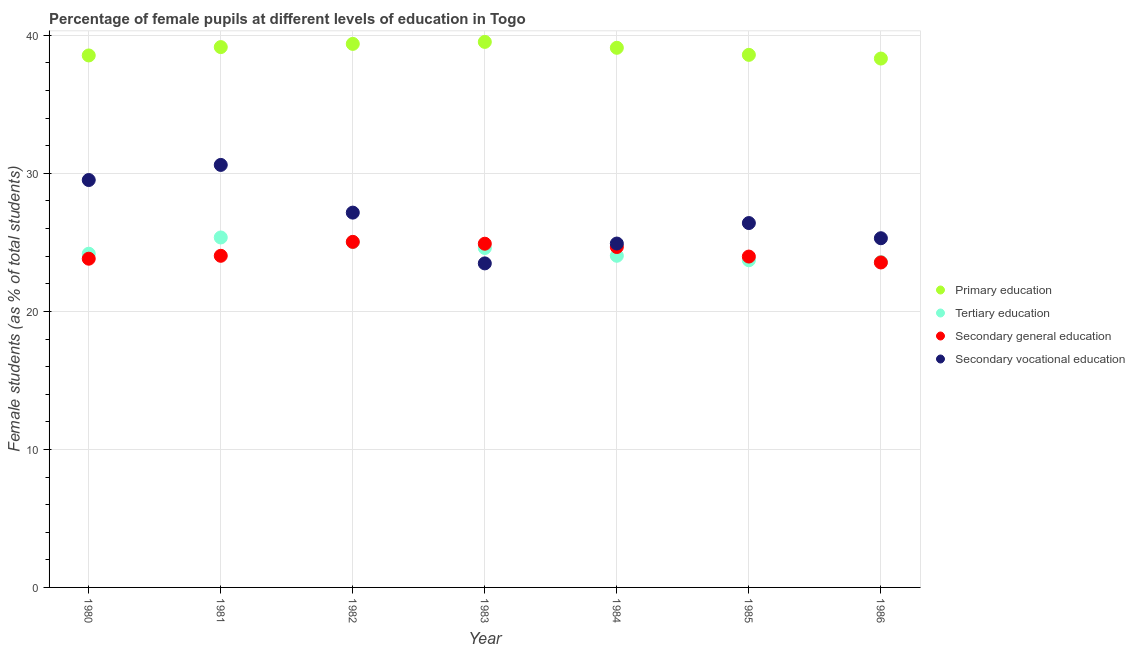What is the percentage of female students in tertiary education in 1981?
Make the answer very short. 25.36. Across all years, what is the maximum percentage of female students in secondary vocational education?
Your response must be concise. 30.61. Across all years, what is the minimum percentage of female students in primary education?
Give a very brief answer. 38.32. In which year was the percentage of female students in secondary vocational education minimum?
Your answer should be compact. 1983. What is the total percentage of female students in primary education in the graph?
Provide a short and direct response. 272.62. What is the difference between the percentage of female students in secondary education in 1980 and that in 1981?
Your answer should be very brief. -0.21. What is the difference between the percentage of female students in secondary education in 1986 and the percentage of female students in tertiary education in 1984?
Ensure brevity in your answer.  -0.49. What is the average percentage of female students in tertiary education per year?
Your answer should be compact. 24.35. In the year 1984, what is the difference between the percentage of female students in tertiary education and percentage of female students in secondary education?
Give a very brief answer. -0.63. What is the ratio of the percentage of female students in tertiary education in 1982 to that in 1985?
Keep it short and to the point. 1.06. Is the difference between the percentage of female students in tertiary education in 1981 and 1984 greater than the difference between the percentage of female students in primary education in 1981 and 1984?
Provide a succinct answer. Yes. What is the difference between the highest and the second highest percentage of female students in secondary vocational education?
Your answer should be very brief. 1.09. What is the difference between the highest and the lowest percentage of female students in tertiary education?
Your answer should be very brief. 1.79. In how many years, is the percentage of female students in tertiary education greater than the average percentage of female students in tertiary education taken over all years?
Provide a short and direct response. 3. Is the sum of the percentage of female students in primary education in 1983 and 1985 greater than the maximum percentage of female students in secondary vocational education across all years?
Ensure brevity in your answer.  Yes. Is it the case that in every year, the sum of the percentage of female students in primary education and percentage of female students in tertiary education is greater than the percentage of female students in secondary education?
Ensure brevity in your answer.  Yes. Does the percentage of female students in secondary education monotonically increase over the years?
Make the answer very short. No. How many dotlines are there?
Your answer should be very brief. 4. What is the difference between two consecutive major ticks on the Y-axis?
Offer a terse response. 10. Are the values on the major ticks of Y-axis written in scientific E-notation?
Offer a very short reply. No. Does the graph contain any zero values?
Give a very brief answer. No. Does the graph contain grids?
Give a very brief answer. Yes. Where does the legend appear in the graph?
Provide a short and direct response. Center right. How many legend labels are there?
Make the answer very short. 4. How are the legend labels stacked?
Your response must be concise. Vertical. What is the title of the graph?
Your response must be concise. Percentage of female pupils at different levels of education in Togo. Does "Public resource use" appear as one of the legend labels in the graph?
Your response must be concise. No. What is the label or title of the Y-axis?
Your answer should be very brief. Female students (as % of total students). What is the Female students (as % of total students) in Primary education in 1980?
Your answer should be compact. 38.55. What is the Female students (as % of total students) in Tertiary education in 1980?
Offer a terse response. 24.18. What is the Female students (as % of total students) of Secondary general education in 1980?
Provide a short and direct response. 23.82. What is the Female students (as % of total students) of Secondary vocational education in 1980?
Ensure brevity in your answer.  29.52. What is the Female students (as % of total students) in Primary education in 1981?
Ensure brevity in your answer.  39.15. What is the Female students (as % of total students) of Tertiary education in 1981?
Offer a very short reply. 25.36. What is the Female students (as % of total students) in Secondary general education in 1981?
Keep it short and to the point. 24.03. What is the Female students (as % of total students) in Secondary vocational education in 1981?
Ensure brevity in your answer.  30.61. What is the Female students (as % of total students) of Primary education in 1982?
Provide a short and direct response. 39.38. What is the Female students (as % of total students) of Tertiary education in 1982?
Ensure brevity in your answer.  25.02. What is the Female students (as % of total students) in Secondary general education in 1982?
Give a very brief answer. 25.04. What is the Female students (as % of total students) of Secondary vocational education in 1982?
Your answer should be compact. 27.16. What is the Female students (as % of total students) of Primary education in 1983?
Your answer should be very brief. 39.53. What is the Female students (as % of total students) of Tertiary education in 1983?
Your response must be concise. 24.59. What is the Female students (as % of total students) in Secondary general education in 1983?
Your response must be concise. 24.9. What is the Female students (as % of total students) of Secondary vocational education in 1983?
Your answer should be compact. 23.48. What is the Female students (as % of total students) in Primary education in 1984?
Keep it short and to the point. 39.1. What is the Female students (as % of total students) of Tertiary education in 1984?
Give a very brief answer. 24.03. What is the Female students (as % of total students) in Secondary general education in 1984?
Your answer should be compact. 24.67. What is the Female students (as % of total students) of Secondary vocational education in 1984?
Provide a short and direct response. 24.92. What is the Female students (as % of total students) in Primary education in 1985?
Make the answer very short. 38.59. What is the Female students (as % of total students) of Tertiary education in 1985?
Keep it short and to the point. 23.71. What is the Female students (as % of total students) of Secondary general education in 1985?
Ensure brevity in your answer.  23.97. What is the Female students (as % of total students) of Secondary vocational education in 1985?
Offer a terse response. 26.4. What is the Female students (as % of total students) in Primary education in 1986?
Make the answer very short. 38.32. What is the Female students (as % of total students) of Tertiary education in 1986?
Ensure brevity in your answer.  23.57. What is the Female students (as % of total students) in Secondary general education in 1986?
Offer a terse response. 23.55. What is the Female students (as % of total students) of Secondary vocational education in 1986?
Offer a very short reply. 25.3. Across all years, what is the maximum Female students (as % of total students) of Primary education?
Give a very brief answer. 39.53. Across all years, what is the maximum Female students (as % of total students) in Tertiary education?
Offer a terse response. 25.36. Across all years, what is the maximum Female students (as % of total students) of Secondary general education?
Ensure brevity in your answer.  25.04. Across all years, what is the maximum Female students (as % of total students) of Secondary vocational education?
Provide a succinct answer. 30.61. Across all years, what is the minimum Female students (as % of total students) of Primary education?
Offer a very short reply. 38.32. Across all years, what is the minimum Female students (as % of total students) in Tertiary education?
Offer a very short reply. 23.57. Across all years, what is the minimum Female students (as % of total students) in Secondary general education?
Give a very brief answer. 23.55. Across all years, what is the minimum Female students (as % of total students) in Secondary vocational education?
Your answer should be very brief. 23.48. What is the total Female students (as % of total students) of Primary education in the graph?
Offer a very short reply. 272.62. What is the total Female students (as % of total students) in Tertiary education in the graph?
Ensure brevity in your answer.  170.47. What is the total Female students (as % of total students) in Secondary general education in the graph?
Your answer should be very brief. 169.98. What is the total Female students (as % of total students) of Secondary vocational education in the graph?
Your response must be concise. 187.39. What is the difference between the Female students (as % of total students) of Primary education in 1980 and that in 1981?
Your response must be concise. -0.61. What is the difference between the Female students (as % of total students) in Tertiary education in 1980 and that in 1981?
Your answer should be compact. -1.18. What is the difference between the Female students (as % of total students) of Secondary general education in 1980 and that in 1981?
Offer a terse response. -0.21. What is the difference between the Female students (as % of total students) in Secondary vocational education in 1980 and that in 1981?
Make the answer very short. -1.09. What is the difference between the Female students (as % of total students) in Primary education in 1980 and that in 1982?
Keep it short and to the point. -0.84. What is the difference between the Female students (as % of total students) of Tertiary education in 1980 and that in 1982?
Your answer should be compact. -0.84. What is the difference between the Female students (as % of total students) of Secondary general education in 1980 and that in 1982?
Offer a very short reply. -1.22. What is the difference between the Female students (as % of total students) of Secondary vocational education in 1980 and that in 1982?
Your response must be concise. 2.36. What is the difference between the Female students (as % of total students) in Primary education in 1980 and that in 1983?
Ensure brevity in your answer.  -0.98. What is the difference between the Female students (as % of total students) of Tertiary education in 1980 and that in 1983?
Provide a succinct answer. -0.42. What is the difference between the Female students (as % of total students) in Secondary general education in 1980 and that in 1983?
Offer a terse response. -1.09. What is the difference between the Female students (as % of total students) of Secondary vocational education in 1980 and that in 1983?
Keep it short and to the point. 6.04. What is the difference between the Female students (as % of total students) of Primary education in 1980 and that in 1984?
Your answer should be compact. -0.55. What is the difference between the Female students (as % of total students) of Tertiary education in 1980 and that in 1984?
Keep it short and to the point. 0.15. What is the difference between the Female students (as % of total students) in Secondary general education in 1980 and that in 1984?
Provide a short and direct response. -0.85. What is the difference between the Female students (as % of total students) in Secondary vocational education in 1980 and that in 1984?
Ensure brevity in your answer.  4.6. What is the difference between the Female students (as % of total students) of Primary education in 1980 and that in 1985?
Provide a short and direct response. -0.04. What is the difference between the Female students (as % of total students) of Tertiary education in 1980 and that in 1985?
Your response must be concise. 0.47. What is the difference between the Female students (as % of total students) in Secondary general education in 1980 and that in 1985?
Offer a very short reply. -0.16. What is the difference between the Female students (as % of total students) in Secondary vocational education in 1980 and that in 1985?
Offer a terse response. 3.12. What is the difference between the Female students (as % of total students) in Primary education in 1980 and that in 1986?
Your answer should be compact. 0.22. What is the difference between the Female students (as % of total students) of Tertiary education in 1980 and that in 1986?
Give a very brief answer. 0.61. What is the difference between the Female students (as % of total students) of Secondary general education in 1980 and that in 1986?
Provide a short and direct response. 0.27. What is the difference between the Female students (as % of total students) of Secondary vocational education in 1980 and that in 1986?
Provide a short and direct response. 4.22. What is the difference between the Female students (as % of total students) in Primary education in 1981 and that in 1982?
Keep it short and to the point. -0.23. What is the difference between the Female students (as % of total students) in Tertiary education in 1981 and that in 1982?
Make the answer very short. 0.33. What is the difference between the Female students (as % of total students) in Secondary general education in 1981 and that in 1982?
Offer a very short reply. -1.01. What is the difference between the Female students (as % of total students) of Secondary vocational education in 1981 and that in 1982?
Give a very brief answer. 3.46. What is the difference between the Female students (as % of total students) of Primary education in 1981 and that in 1983?
Your answer should be compact. -0.38. What is the difference between the Female students (as % of total students) in Tertiary education in 1981 and that in 1983?
Your answer should be very brief. 0.76. What is the difference between the Female students (as % of total students) of Secondary general education in 1981 and that in 1983?
Make the answer very short. -0.88. What is the difference between the Female students (as % of total students) in Secondary vocational education in 1981 and that in 1983?
Ensure brevity in your answer.  7.14. What is the difference between the Female students (as % of total students) in Primary education in 1981 and that in 1984?
Give a very brief answer. 0.05. What is the difference between the Female students (as % of total students) in Tertiary education in 1981 and that in 1984?
Ensure brevity in your answer.  1.33. What is the difference between the Female students (as % of total students) of Secondary general education in 1981 and that in 1984?
Offer a very short reply. -0.64. What is the difference between the Female students (as % of total students) in Secondary vocational education in 1981 and that in 1984?
Provide a succinct answer. 5.7. What is the difference between the Female students (as % of total students) of Primary education in 1981 and that in 1985?
Provide a succinct answer. 0.56. What is the difference between the Female students (as % of total students) in Tertiary education in 1981 and that in 1985?
Give a very brief answer. 1.65. What is the difference between the Female students (as % of total students) of Secondary general education in 1981 and that in 1985?
Your answer should be very brief. 0.05. What is the difference between the Female students (as % of total students) of Secondary vocational education in 1981 and that in 1985?
Your answer should be compact. 4.21. What is the difference between the Female students (as % of total students) in Primary education in 1981 and that in 1986?
Make the answer very short. 0.83. What is the difference between the Female students (as % of total students) in Tertiary education in 1981 and that in 1986?
Give a very brief answer. 1.79. What is the difference between the Female students (as % of total students) in Secondary general education in 1981 and that in 1986?
Your response must be concise. 0.48. What is the difference between the Female students (as % of total students) of Secondary vocational education in 1981 and that in 1986?
Provide a short and direct response. 5.31. What is the difference between the Female students (as % of total students) in Primary education in 1982 and that in 1983?
Ensure brevity in your answer.  -0.14. What is the difference between the Female students (as % of total students) in Tertiary education in 1982 and that in 1983?
Offer a terse response. 0.43. What is the difference between the Female students (as % of total students) of Secondary general education in 1982 and that in 1983?
Provide a succinct answer. 0.13. What is the difference between the Female students (as % of total students) in Secondary vocational education in 1982 and that in 1983?
Provide a succinct answer. 3.68. What is the difference between the Female students (as % of total students) in Primary education in 1982 and that in 1984?
Offer a very short reply. 0.28. What is the difference between the Female students (as % of total students) of Secondary general education in 1982 and that in 1984?
Keep it short and to the point. 0.37. What is the difference between the Female students (as % of total students) of Secondary vocational education in 1982 and that in 1984?
Offer a terse response. 2.24. What is the difference between the Female students (as % of total students) of Primary education in 1982 and that in 1985?
Ensure brevity in your answer.  0.79. What is the difference between the Female students (as % of total students) in Tertiary education in 1982 and that in 1985?
Offer a very short reply. 1.32. What is the difference between the Female students (as % of total students) in Secondary general education in 1982 and that in 1985?
Offer a terse response. 1.06. What is the difference between the Female students (as % of total students) in Secondary vocational education in 1982 and that in 1985?
Keep it short and to the point. 0.76. What is the difference between the Female students (as % of total students) of Primary education in 1982 and that in 1986?
Ensure brevity in your answer.  1.06. What is the difference between the Female students (as % of total students) of Tertiary education in 1982 and that in 1986?
Keep it short and to the point. 1.45. What is the difference between the Female students (as % of total students) in Secondary general education in 1982 and that in 1986?
Keep it short and to the point. 1.49. What is the difference between the Female students (as % of total students) of Secondary vocational education in 1982 and that in 1986?
Provide a succinct answer. 1.86. What is the difference between the Female students (as % of total students) of Primary education in 1983 and that in 1984?
Make the answer very short. 0.43. What is the difference between the Female students (as % of total students) of Tertiary education in 1983 and that in 1984?
Keep it short and to the point. 0.56. What is the difference between the Female students (as % of total students) in Secondary general education in 1983 and that in 1984?
Your response must be concise. 0.24. What is the difference between the Female students (as % of total students) in Secondary vocational education in 1983 and that in 1984?
Provide a short and direct response. -1.44. What is the difference between the Female students (as % of total students) of Primary education in 1983 and that in 1985?
Give a very brief answer. 0.94. What is the difference between the Female students (as % of total students) in Tertiary education in 1983 and that in 1985?
Offer a very short reply. 0.89. What is the difference between the Female students (as % of total students) of Secondary general education in 1983 and that in 1985?
Provide a short and direct response. 0.93. What is the difference between the Female students (as % of total students) in Secondary vocational education in 1983 and that in 1985?
Keep it short and to the point. -2.92. What is the difference between the Female students (as % of total students) of Primary education in 1983 and that in 1986?
Ensure brevity in your answer.  1.21. What is the difference between the Female students (as % of total students) in Tertiary education in 1983 and that in 1986?
Make the answer very short. 1.02. What is the difference between the Female students (as % of total students) of Secondary general education in 1983 and that in 1986?
Offer a terse response. 1.36. What is the difference between the Female students (as % of total students) of Secondary vocational education in 1983 and that in 1986?
Offer a very short reply. -1.82. What is the difference between the Female students (as % of total students) of Primary education in 1984 and that in 1985?
Provide a short and direct response. 0.51. What is the difference between the Female students (as % of total students) of Tertiary education in 1984 and that in 1985?
Your answer should be very brief. 0.32. What is the difference between the Female students (as % of total students) of Secondary general education in 1984 and that in 1985?
Provide a short and direct response. 0.69. What is the difference between the Female students (as % of total students) in Secondary vocational education in 1984 and that in 1985?
Ensure brevity in your answer.  -1.48. What is the difference between the Female students (as % of total students) in Primary education in 1984 and that in 1986?
Offer a very short reply. 0.78. What is the difference between the Female students (as % of total students) in Tertiary education in 1984 and that in 1986?
Provide a succinct answer. 0.46. What is the difference between the Female students (as % of total students) in Secondary general education in 1984 and that in 1986?
Offer a very short reply. 1.12. What is the difference between the Female students (as % of total students) in Secondary vocational education in 1984 and that in 1986?
Make the answer very short. -0.38. What is the difference between the Female students (as % of total students) of Primary education in 1985 and that in 1986?
Make the answer very short. 0.27. What is the difference between the Female students (as % of total students) in Tertiary education in 1985 and that in 1986?
Offer a terse response. 0.14. What is the difference between the Female students (as % of total students) of Secondary general education in 1985 and that in 1986?
Make the answer very short. 0.43. What is the difference between the Female students (as % of total students) in Secondary vocational education in 1985 and that in 1986?
Give a very brief answer. 1.1. What is the difference between the Female students (as % of total students) of Primary education in 1980 and the Female students (as % of total students) of Tertiary education in 1981?
Make the answer very short. 13.19. What is the difference between the Female students (as % of total students) of Primary education in 1980 and the Female students (as % of total students) of Secondary general education in 1981?
Ensure brevity in your answer.  14.52. What is the difference between the Female students (as % of total students) in Primary education in 1980 and the Female students (as % of total students) in Secondary vocational education in 1981?
Keep it short and to the point. 7.93. What is the difference between the Female students (as % of total students) in Tertiary education in 1980 and the Female students (as % of total students) in Secondary general education in 1981?
Your response must be concise. 0.15. What is the difference between the Female students (as % of total students) of Tertiary education in 1980 and the Female students (as % of total students) of Secondary vocational education in 1981?
Offer a very short reply. -6.43. What is the difference between the Female students (as % of total students) in Secondary general education in 1980 and the Female students (as % of total students) in Secondary vocational education in 1981?
Provide a succinct answer. -6.8. What is the difference between the Female students (as % of total students) of Primary education in 1980 and the Female students (as % of total students) of Tertiary education in 1982?
Your answer should be very brief. 13.52. What is the difference between the Female students (as % of total students) of Primary education in 1980 and the Female students (as % of total students) of Secondary general education in 1982?
Offer a very short reply. 13.51. What is the difference between the Female students (as % of total students) of Primary education in 1980 and the Female students (as % of total students) of Secondary vocational education in 1982?
Provide a succinct answer. 11.39. What is the difference between the Female students (as % of total students) of Tertiary education in 1980 and the Female students (as % of total students) of Secondary general education in 1982?
Offer a terse response. -0.86. What is the difference between the Female students (as % of total students) of Tertiary education in 1980 and the Female students (as % of total students) of Secondary vocational education in 1982?
Provide a succinct answer. -2.98. What is the difference between the Female students (as % of total students) in Secondary general education in 1980 and the Female students (as % of total students) in Secondary vocational education in 1982?
Keep it short and to the point. -3.34. What is the difference between the Female students (as % of total students) of Primary education in 1980 and the Female students (as % of total students) of Tertiary education in 1983?
Your answer should be compact. 13.95. What is the difference between the Female students (as % of total students) in Primary education in 1980 and the Female students (as % of total students) in Secondary general education in 1983?
Your answer should be very brief. 13.64. What is the difference between the Female students (as % of total students) in Primary education in 1980 and the Female students (as % of total students) in Secondary vocational education in 1983?
Provide a short and direct response. 15.07. What is the difference between the Female students (as % of total students) of Tertiary education in 1980 and the Female students (as % of total students) of Secondary general education in 1983?
Offer a terse response. -0.73. What is the difference between the Female students (as % of total students) in Tertiary education in 1980 and the Female students (as % of total students) in Secondary vocational education in 1983?
Your answer should be compact. 0.7. What is the difference between the Female students (as % of total students) of Secondary general education in 1980 and the Female students (as % of total students) of Secondary vocational education in 1983?
Provide a short and direct response. 0.34. What is the difference between the Female students (as % of total students) in Primary education in 1980 and the Female students (as % of total students) in Tertiary education in 1984?
Your answer should be compact. 14.52. What is the difference between the Female students (as % of total students) of Primary education in 1980 and the Female students (as % of total students) of Secondary general education in 1984?
Your answer should be very brief. 13.88. What is the difference between the Female students (as % of total students) in Primary education in 1980 and the Female students (as % of total students) in Secondary vocational education in 1984?
Give a very brief answer. 13.63. What is the difference between the Female students (as % of total students) in Tertiary education in 1980 and the Female students (as % of total students) in Secondary general education in 1984?
Your answer should be very brief. -0.49. What is the difference between the Female students (as % of total students) in Tertiary education in 1980 and the Female students (as % of total students) in Secondary vocational education in 1984?
Give a very brief answer. -0.74. What is the difference between the Female students (as % of total students) in Secondary general education in 1980 and the Female students (as % of total students) in Secondary vocational education in 1984?
Offer a terse response. -1.1. What is the difference between the Female students (as % of total students) of Primary education in 1980 and the Female students (as % of total students) of Tertiary education in 1985?
Offer a terse response. 14.84. What is the difference between the Female students (as % of total students) in Primary education in 1980 and the Female students (as % of total students) in Secondary general education in 1985?
Your answer should be very brief. 14.57. What is the difference between the Female students (as % of total students) of Primary education in 1980 and the Female students (as % of total students) of Secondary vocational education in 1985?
Give a very brief answer. 12.14. What is the difference between the Female students (as % of total students) in Tertiary education in 1980 and the Female students (as % of total students) in Secondary general education in 1985?
Your answer should be very brief. 0.2. What is the difference between the Female students (as % of total students) of Tertiary education in 1980 and the Female students (as % of total students) of Secondary vocational education in 1985?
Give a very brief answer. -2.22. What is the difference between the Female students (as % of total students) of Secondary general education in 1980 and the Female students (as % of total students) of Secondary vocational education in 1985?
Ensure brevity in your answer.  -2.58. What is the difference between the Female students (as % of total students) in Primary education in 1980 and the Female students (as % of total students) in Tertiary education in 1986?
Your answer should be very brief. 14.97. What is the difference between the Female students (as % of total students) of Primary education in 1980 and the Female students (as % of total students) of Secondary general education in 1986?
Provide a short and direct response. 15. What is the difference between the Female students (as % of total students) of Primary education in 1980 and the Female students (as % of total students) of Secondary vocational education in 1986?
Offer a very short reply. 13.24. What is the difference between the Female students (as % of total students) of Tertiary education in 1980 and the Female students (as % of total students) of Secondary general education in 1986?
Your answer should be compact. 0.63. What is the difference between the Female students (as % of total students) of Tertiary education in 1980 and the Female students (as % of total students) of Secondary vocational education in 1986?
Offer a terse response. -1.12. What is the difference between the Female students (as % of total students) in Secondary general education in 1980 and the Female students (as % of total students) in Secondary vocational education in 1986?
Ensure brevity in your answer.  -1.48. What is the difference between the Female students (as % of total students) in Primary education in 1981 and the Female students (as % of total students) in Tertiary education in 1982?
Your response must be concise. 14.13. What is the difference between the Female students (as % of total students) of Primary education in 1981 and the Female students (as % of total students) of Secondary general education in 1982?
Your answer should be very brief. 14.11. What is the difference between the Female students (as % of total students) of Primary education in 1981 and the Female students (as % of total students) of Secondary vocational education in 1982?
Your answer should be very brief. 11.99. What is the difference between the Female students (as % of total students) of Tertiary education in 1981 and the Female students (as % of total students) of Secondary general education in 1982?
Keep it short and to the point. 0.32. What is the difference between the Female students (as % of total students) of Tertiary education in 1981 and the Female students (as % of total students) of Secondary vocational education in 1982?
Your response must be concise. -1.8. What is the difference between the Female students (as % of total students) in Secondary general education in 1981 and the Female students (as % of total students) in Secondary vocational education in 1982?
Ensure brevity in your answer.  -3.13. What is the difference between the Female students (as % of total students) of Primary education in 1981 and the Female students (as % of total students) of Tertiary education in 1983?
Your answer should be compact. 14.56. What is the difference between the Female students (as % of total students) in Primary education in 1981 and the Female students (as % of total students) in Secondary general education in 1983?
Your answer should be compact. 14.25. What is the difference between the Female students (as % of total students) of Primary education in 1981 and the Female students (as % of total students) of Secondary vocational education in 1983?
Offer a terse response. 15.67. What is the difference between the Female students (as % of total students) of Tertiary education in 1981 and the Female students (as % of total students) of Secondary general education in 1983?
Provide a short and direct response. 0.45. What is the difference between the Female students (as % of total students) of Tertiary education in 1981 and the Female students (as % of total students) of Secondary vocational education in 1983?
Offer a terse response. 1.88. What is the difference between the Female students (as % of total students) in Secondary general education in 1981 and the Female students (as % of total students) in Secondary vocational education in 1983?
Your answer should be very brief. 0.55. What is the difference between the Female students (as % of total students) in Primary education in 1981 and the Female students (as % of total students) in Tertiary education in 1984?
Keep it short and to the point. 15.12. What is the difference between the Female students (as % of total students) in Primary education in 1981 and the Female students (as % of total students) in Secondary general education in 1984?
Give a very brief answer. 14.49. What is the difference between the Female students (as % of total students) of Primary education in 1981 and the Female students (as % of total students) of Secondary vocational education in 1984?
Keep it short and to the point. 14.23. What is the difference between the Female students (as % of total students) of Tertiary education in 1981 and the Female students (as % of total students) of Secondary general education in 1984?
Provide a short and direct response. 0.69. What is the difference between the Female students (as % of total students) of Tertiary education in 1981 and the Female students (as % of total students) of Secondary vocational education in 1984?
Give a very brief answer. 0.44. What is the difference between the Female students (as % of total students) in Secondary general education in 1981 and the Female students (as % of total students) in Secondary vocational education in 1984?
Provide a succinct answer. -0.89. What is the difference between the Female students (as % of total students) of Primary education in 1981 and the Female students (as % of total students) of Tertiary education in 1985?
Ensure brevity in your answer.  15.44. What is the difference between the Female students (as % of total students) of Primary education in 1981 and the Female students (as % of total students) of Secondary general education in 1985?
Your response must be concise. 15.18. What is the difference between the Female students (as % of total students) of Primary education in 1981 and the Female students (as % of total students) of Secondary vocational education in 1985?
Ensure brevity in your answer.  12.75. What is the difference between the Female students (as % of total students) in Tertiary education in 1981 and the Female students (as % of total students) in Secondary general education in 1985?
Ensure brevity in your answer.  1.38. What is the difference between the Female students (as % of total students) of Tertiary education in 1981 and the Female students (as % of total students) of Secondary vocational education in 1985?
Keep it short and to the point. -1.04. What is the difference between the Female students (as % of total students) in Secondary general education in 1981 and the Female students (as % of total students) in Secondary vocational education in 1985?
Give a very brief answer. -2.37. What is the difference between the Female students (as % of total students) of Primary education in 1981 and the Female students (as % of total students) of Tertiary education in 1986?
Provide a succinct answer. 15.58. What is the difference between the Female students (as % of total students) in Primary education in 1981 and the Female students (as % of total students) in Secondary general education in 1986?
Offer a terse response. 15.61. What is the difference between the Female students (as % of total students) in Primary education in 1981 and the Female students (as % of total students) in Secondary vocational education in 1986?
Your answer should be very brief. 13.85. What is the difference between the Female students (as % of total students) in Tertiary education in 1981 and the Female students (as % of total students) in Secondary general education in 1986?
Your answer should be compact. 1.81. What is the difference between the Female students (as % of total students) in Tertiary education in 1981 and the Female students (as % of total students) in Secondary vocational education in 1986?
Ensure brevity in your answer.  0.05. What is the difference between the Female students (as % of total students) of Secondary general education in 1981 and the Female students (as % of total students) of Secondary vocational education in 1986?
Offer a very short reply. -1.27. What is the difference between the Female students (as % of total students) of Primary education in 1982 and the Female students (as % of total students) of Tertiary education in 1983?
Offer a very short reply. 14.79. What is the difference between the Female students (as % of total students) in Primary education in 1982 and the Female students (as % of total students) in Secondary general education in 1983?
Make the answer very short. 14.48. What is the difference between the Female students (as % of total students) in Primary education in 1982 and the Female students (as % of total students) in Secondary vocational education in 1983?
Provide a succinct answer. 15.91. What is the difference between the Female students (as % of total students) in Tertiary education in 1982 and the Female students (as % of total students) in Secondary general education in 1983?
Offer a terse response. 0.12. What is the difference between the Female students (as % of total students) in Tertiary education in 1982 and the Female students (as % of total students) in Secondary vocational education in 1983?
Your response must be concise. 1.54. What is the difference between the Female students (as % of total students) of Secondary general education in 1982 and the Female students (as % of total students) of Secondary vocational education in 1983?
Make the answer very short. 1.56. What is the difference between the Female students (as % of total students) of Primary education in 1982 and the Female students (as % of total students) of Tertiary education in 1984?
Your answer should be compact. 15.35. What is the difference between the Female students (as % of total students) in Primary education in 1982 and the Female students (as % of total students) in Secondary general education in 1984?
Keep it short and to the point. 14.72. What is the difference between the Female students (as % of total students) in Primary education in 1982 and the Female students (as % of total students) in Secondary vocational education in 1984?
Give a very brief answer. 14.47. What is the difference between the Female students (as % of total students) in Tertiary education in 1982 and the Female students (as % of total students) in Secondary general education in 1984?
Ensure brevity in your answer.  0.36. What is the difference between the Female students (as % of total students) in Tertiary education in 1982 and the Female students (as % of total students) in Secondary vocational education in 1984?
Your answer should be very brief. 0.11. What is the difference between the Female students (as % of total students) of Secondary general education in 1982 and the Female students (as % of total students) of Secondary vocational education in 1984?
Offer a very short reply. 0.12. What is the difference between the Female students (as % of total students) of Primary education in 1982 and the Female students (as % of total students) of Tertiary education in 1985?
Keep it short and to the point. 15.68. What is the difference between the Female students (as % of total students) of Primary education in 1982 and the Female students (as % of total students) of Secondary general education in 1985?
Keep it short and to the point. 15.41. What is the difference between the Female students (as % of total students) of Primary education in 1982 and the Female students (as % of total students) of Secondary vocational education in 1985?
Offer a very short reply. 12.98. What is the difference between the Female students (as % of total students) in Tertiary education in 1982 and the Female students (as % of total students) in Secondary general education in 1985?
Your answer should be compact. 1.05. What is the difference between the Female students (as % of total students) in Tertiary education in 1982 and the Female students (as % of total students) in Secondary vocational education in 1985?
Your response must be concise. -1.38. What is the difference between the Female students (as % of total students) of Secondary general education in 1982 and the Female students (as % of total students) of Secondary vocational education in 1985?
Give a very brief answer. -1.36. What is the difference between the Female students (as % of total students) in Primary education in 1982 and the Female students (as % of total students) in Tertiary education in 1986?
Provide a short and direct response. 15.81. What is the difference between the Female students (as % of total students) in Primary education in 1982 and the Female students (as % of total students) in Secondary general education in 1986?
Your answer should be very brief. 15.84. What is the difference between the Female students (as % of total students) in Primary education in 1982 and the Female students (as % of total students) in Secondary vocational education in 1986?
Your response must be concise. 14.08. What is the difference between the Female students (as % of total students) of Tertiary education in 1982 and the Female students (as % of total students) of Secondary general education in 1986?
Make the answer very short. 1.48. What is the difference between the Female students (as % of total students) in Tertiary education in 1982 and the Female students (as % of total students) in Secondary vocational education in 1986?
Make the answer very short. -0.28. What is the difference between the Female students (as % of total students) of Secondary general education in 1982 and the Female students (as % of total students) of Secondary vocational education in 1986?
Keep it short and to the point. -0.26. What is the difference between the Female students (as % of total students) in Primary education in 1983 and the Female students (as % of total students) in Tertiary education in 1984?
Keep it short and to the point. 15.5. What is the difference between the Female students (as % of total students) in Primary education in 1983 and the Female students (as % of total students) in Secondary general education in 1984?
Make the answer very short. 14.86. What is the difference between the Female students (as % of total students) in Primary education in 1983 and the Female students (as % of total students) in Secondary vocational education in 1984?
Make the answer very short. 14.61. What is the difference between the Female students (as % of total students) in Tertiary education in 1983 and the Female students (as % of total students) in Secondary general education in 1984?
Make the answer very short. -0.07. What is the difference between the Female students (as % of total students) of Tertiary education in 1983 and the Female students (as % of total students) of Secondary vocational education in 1984?
Keep it short and to the point. -0.32. What is the difference between the Female students (as % of total students) in Secondary general education in 1983 and the Female students (as % of total students) in Secondary vocational education in 1984?
Your answer should be very brief. -0.01. What is the difference between the Female students (as % of total students) of Primary education in 1983 and the Female students (as % of total students) of Tertiary education in 1985?
Give a very brief answer. 15.82. What is the difference between the Female students (as % of total students) of Primary education in 1983 and the Female students (as % of total students) of Secondary general education in 1985?
Offer a very short reply. 15.55. What is the difference between the Female students (as % of total students) in Primary education in 1983 and the Female students (as % of total students) in Secondary vocational education in 1985?
Your answer should be very brief. 13.13. What is the difference between the Female students (as % of total students) in Tertiary education in 1983 and the Female students (as % of total students) in Secondary general education in 1985?
Give a very brief answer. 0.62. What is the difference between the Female students (as % of total students) in Tertiary education in 1983 and the Female students (as % of total students) in Secondary vocational education in 1985?
Make the answer very short. -1.81. What is the difference between the Female students (as % of total students) of Secondary general education in 1983 and the Female students (as % of total students) of Secondary vocational education in 1985?
Offer a very short reply. -1.5. What is the difference between the Female students (as % of total students) in Primary education in 1983 and the Female students (as % of total students) in Tertiary education in 1986?
Make the answer very short. 15.96. What is the difference between the Female students (as % of total students) of Primary education in 1983 and the Female students (as % of total students) of Secondary general education in 1986?
Your response must be concise. 15.98. What is the difference between the Female students (as % of total students) of Primary education in 1983 and the Female students (as % of total students) of Secondary vocational education in 1986?
Make the answer very short. 14.23. What is the difference between the Female students (as % of total students) of Tertiary education in 1983 and the Female students (as % of total students) of Secondary general education in 1986?
Provide a succinct answer. 1.05. What is the difference between the Female students (as % of total students) of Tertiary education in 1983 and the Female students (as % of total students) of Secondary vocational education in 1986?
Offer a very short reply. -0.71. What is the difference between the Female students (as % of total students) in Secondary general education in 1983 and the Female students (as % of total students) in Secondary vocational education in 1986?
Provide a succinct answer. -0.4. What is the difference between the Female students (as % of total students) in Primary education in 1984 and the Female students (as % of total students) in Tertiary education in 1985?
Ensure brevity in your answer.  15.39. What is the difference between the Female students (as % of total students) in Primary education in 1984 and the Female students (as % of total students) in Secondary general education in 1985?
Your response must be concise. 15.13. What is the difference between the Female students (as % of total students) in Primary education in 1984 and the Female students (as % of total students) in Secondary vocational education in 1985?
Your answer should be very brief. 12.7. What is the difference between the Female students (as % of total students) in Tertiary education in 1984 and the Female students (as % of total students) in Secondary general education in 1985?
Make the answer very short. 0.06. What is the difference between the Female students (as % of total students) of Tertiary education in 1984 and the Female students (as % of total students) of Secondary vocational education in 1985?
Your response must be concise. -2.37. What is the difference between the Female students (as % of total students) of Secondary general education in 1984 and the Female students (as % of total students) of Secondary vocational education in 1985?
Ensure brevity in your answer.  -1.74. What is the difference between the Female students (as % of total students) in Primary education in 1984 and the Female students (as % of total students) in Tertiary education in 1986?
Offer a terse response. 15.53. What is the difference between the Female students (as % of total students) in Primary education in 1984 and the Female students (as % of total students) in Secondary general education in 1986?
Offer a terse response. 15.55. What is the difference between the Female students (as % of total students) of Primary education in 1984 and the Female students (as % of total students) of Secondary vocational education in 1986?
Provide a succinct answer. 13.8. What is the difference between the Female students (as % of total students) of Tertiary education in 1984 and the Female students (as % of total students) of Secondary general education in 1986?
Offer a terse response. 0.49. What is the difference between the Female students (as % of total students) of Tertiary education in 1984 and the Female students (as % of total students) of Secondary vocational education in 1986?
Your answer should be very brief. -1.27. What is the difference between the Female students (as % of total students) of Secondary general education in 1984 and the Female students (as % of total students) of Secondary vocational education in 1986?
Give a very brief answer. -0.64. What is the difference between the Female students (as % of total students) of Primary education in 1985 and the Female students (as % of total students) of Tertiary education in 1986?
Offer a terse response. 15.02. What is the difference between the Female students (as % of total students) in Primary education in 1985 and the Female students (as % of total students) in Secondary general education in 1986?
Keep it short and to the point. 15.04. What is the difference between the Female students (as % of total students) of Primary education in 1985 and the Female students (as % of total students) of Secondary vocational education in 1986?
Offer a terse response. 13.29. What is the difference between the Female students (as % of total students) in Tertiary education in 1985 and the Female students (as % of total students) in Secondary general education in 1986?
Your answer should be very brief. 0.16. What is the difference between the Female students (as % of total students) in Tertiary education in 1985 and the Female students (as % of total students) in Secondary vocational education in 1986?
Give a very brief answer. -1.59. What is the difference between the Female students (as % of total students) of Secondary general education in 1985 and the Female students (as % of total students) of Secondary vocational education in 1986?
Offer a terse response. -1.33. What is the average Female students (as % of total students) of Primary education per year?
Provide a succinct answer. 38.95. What is the average Female students (as % of total students) of Tertiary education per year?
Make the answer very short. 24.35. What is the average Female students (as % of total students) of Secondary general education per year?
Keep it short and to the point. 24.28. What is the average Female students (as % of total students) of Secondary vocational education per year?
Give a very brief answer. 26.77. In the year 1980, what is the difference between the Female students (as % of total students) of Primary education and Female students (as % of total students) of Tertiary education?
Provide a succinct answer. 14.37. In the year 1980, what is the difference between the Female students (as % of total students) of Primary education and Female students (as % of total students) of Secondary general education?
Your response must be concise. 14.73. In the year 1980, what is the difference between the Female students (as % of total students) of Primary education and Female students (as % of total students) of Secondary vocational education?
Your answer should be very brief. 9.03. In the year 1980, what is the difference between the Female students (as % of total students) of Tertiary education and Female students (as % of total students) of Secondary general education?
Provide a succinct answer. 0.36. In the year 1980, what is the difference between the Female students (as % of total students) of Tertiary education and Female students (as % of total students) of Secondary vocational education?
Make the answer very short. -5.34. In the year 1980, what is the difference between the Female students (as % of total students) of Secondary general education and Female students (as % of total students) of Secondary vocational education?
Provide a succinct answer. -5.7. In the year 1981, what is the difference between the Female students (as % of total students) of Primary education and Female students (as % of total students) of Tertiary education?
Keep it short and to the point. 13.79. In the year 1981, what is the difference between the Female students (as % of total students) in Primary education and Female students (as % of total students) in Secondary general education?
Your answer should be very brief. 15.12. In the year 1981, what is the difference between the Female students (as % of total students) of Primary education and Female students (as % of total students) of Secondary vocational education?
Make the answer very short. 8.54. In the year 1981, what is the difference between the Female students (as % of total students) in Tertiary education and Female students (as % of total students) in Secondary general education?
Give a very brief answer. 1.33. In the year 1981, what is the difference between the Female students (as % of total students) of Tertiary education and Female students (as % of total students) of Secondary vocational education?
Provide a short and direct response. -5.26. In the year 1981, what is the difference between the Female students (as % of total students) of Secondary general education and Female students (as % of total students) of Secondary vocational education?
Your response must be concise. -6.58. In the year 1982, what is the difference between the Female students (as % of total students) of Primary education and Female students (as % of total students) of Tertiary education?
Keep it short and to the point. 14.36. In the year 1982, what is the difference between the Female students (as % of total students) in Primary education and Female students (as % of total students) in Secondary general education?
Your answer should be compact. 14.35. In the year 1982, what is the difference between the Female students (as % of total students) of Primary education and Female students (as % of total students) of Secondary vocational education?
Provide a short and direct response. 12.23. In the year 1982, what is the difference between the Female students (as % of total students) of Tertiary education and Female students (as % of total students) of Secondary general education?
Keep it short and to the point. -0.02. In the year 1982, what is the difference between the Female students (as % of total students) in Tertiary education and Female students (as % of total students) in Secondary vocational education?
Your response must be concise. -2.13. In the year 1982, what is the difference between the Female students (as % of total students) in Secondary general education and Female students (as % of total students) in Secondary vocational education?
Your answer should be very brief. -2.12. In the year 1983, what is the difference between the Female students (as % of total students) of Primary education and Female students (as % of total students) of Tertiary education?
Ensure brevity in your answer.  14.93. In the year 1983, what is the difference between the Female students (as % of total students) in Primary education and Female students (as % of total students) in Secondary general education?
Offer a terse response. 14.62. In the year 1983, what is the difference between the Female students (as % of total students) of Primary education and Female students (as % of total students) of Secondary vocational education?
Ensure brevity in your answer.  16.05. In the year 1983, what is the difference between the Female students (as % of total students) of Tertiary education and Female students (as % of total students) of Secondary general education?
Offer a terse response. -0.31. In the year 1983, what is the difference between the Female students (as % of total students) of Tertiary education and Female students (as % of total students) of Secondary vocational education?
Make the answer very short. 1.12. In the year 1983, what is the difference between the Female students (as % of total students) of Secondary general education and Female students (as % of total students) of Secondary vocational education?
Ensure brevity in your answer.  1.43. In the year 1984, what is the difference between the Female students (as % of total students) in Primary education and Female students (as % of total students) in Tertiary education?
Your answer should be very brief. 15.07. In the year 1984, what is the difference between the Female students (as % of total students) of Primary education and Female students (as % of total students) of Secondary general education?
Give a very brief answer. 14.44. In the year 1984, what is the difference between the Female students (as % of total students) of Primary education and Female students (as % of total students) of Secondary vocational education?
Offer a terse response. 14.18. In the year 1984, what is the difference between the Female students (as % of total students) of Tertiary education and Female students (as % of total students) of Secondary general education?
Your response must be concise. -0.63. In the year 1984, what is the difference between the Female students (as % of total students) in Tertiary education and Female students (as % of total students) in Secondary vocational education?
Make the answer very short. -0.89. In the year 1984, what is the difference between the Female students (as % of total students) in Secondary general education and Female students (as % of total students) in Secondary vocational education?
Ensure brevity in your answer.  -0.25. In the year 1985, what is the difference between the Female students (as % of total students) of Primary education and Female students (as % of total students) of Tertiary education?
Your answer should be very brief. 14.88. In the year 1985, what is the difference between the Female students (as % of total students) in Primary education and Female students (as % of total students) in Secondary general education?
Your answer should be very brief. 14.61. In the year 1985, what is the difference between the Female students (as % of total students) in Primary education and Female students (as % of total students) in Secondary vocational education?
Your response must be concise. 12.19. In the year 1985, what is the difference between the Female students (as % of total students) of Tertiary education and Female students (as % of total students) of Secondary general education?
Your answer should be very brief. -0.27. In the year 1985, what is the difference between the Female students (as % of total students) in Tertiary education and Female students (as % of total students) in Secondary vocational education?
Ensure brevity in your answer.  -2.69. In the year 1985, what is the difference between the Female students (as % of total students) of Secondary general education and Female students (as % of total students) of Secondary vocational education?
Offer a terse response. -2.43. In the year 1986, what is the difference between the Female students (as % of total students) of Primary education and Female students (as % of total students) of Tertiary education?
Your answer should be very brief. 14.75. In the year 1986, what is the difference between the Female students (as % of total students) in Primary education and Female students (as % of total students) in Secondary general education?
Offer a terse response. 14.78. In the year 1986, what is the difference between the Female students (as % of total students) of Primary education and Female students (as % of total students) of Secondary vocational education?
Provide a short and direct response. 13.02. In the year 1986, what is the difference between the Female students (as % of total students) in Tertiary education and Female students (as % of total students) in Secondary general education?
Provide a short and direct response. 0.03. In the year 1986, what is the difference between the Female students (as % of total students) in Tertiary education and Female students (as % of total students) in Secondary vocational education?
Your response must be concise. -1.73. In the year 1986, what is the difference between the Female students (as % of total students) in Secondary general education and Female students (as % of total students) in Secondary vocational education?
Offer a very short reply. -1.76. What is the ratio of the Female students (as % of total students) of Primary education in 1980 to that in 1981?
Make the answer very short. 0.98. What is the ratio of the Female students (as % of total students) of Tertiary education in 1980 to that in 1981?
Offer a terse response. 0.95. What is the ratio of the Female students (as % of total students) of Secondary general education in 1980 to that in 1981?
Offer a terse response. 0.99. What is the ratio of the Female students (as % of total students) of Secondary vocational education in 1980 to that in 1981?
Your answer should be very brief. 0.96. What is the ratio of the Female students (as % of total students) of Primary education in 1980 to that in 1982?
Keep it short and to the point. 0.98. What is the ratio of the Female students (as % of total students) in Tertiary education in 1980 to that in 1982?
Your answer should be compact. 0.97. What is the ratio of the Female students (as % of total students) in Secondary general education in 1980 to that in 1982?
Offer a very short reply. 0.95. What is the ratio of the Female students (as % of total students) in Secondary vocational education in 1980 to that in 1982?
Offer a terse response. 1.09. What is the ratio of the Female students (as % of total students) of Primary education in 1980 to that in 1983?
Provide a succinct answer. 0.98. What is the ratio of the Female students (as % of total students) of Tertiary education in 1980 to that in 1983?
Give a very brief answer. 0.98. What is the ratio of the Female students (as % of total students) in Secondary general education in 1980 to that in 1983?
Make the answer very short. 0.96. What is the ratio of the Female students (as % of total students) of Secondary vocational education in 1980 to that in 1983?
Give a very brief answer. 1.26. What is the ratio of the Female students (as % of total students) in Primary education in 1980 to that in 1984?
Offer a very short reply. 0.99. What is the ratio of the Female students (as % of total students) in Secondary general education in 1980 to that in 1984?
Make the answer very short. 0.97. What is the ratio of the Female students (as % of total students) in Secondary vocational education in 1980 to that in 1984?
Ensure brevity in your answer.  1.18. What is the ratio of the Female students (as % of total students) of Tertiary education in 1980 to that in 1985?
Provide a short and direct response. 1.02. What is the ratio of the Female students (as % of total students) of Secondary general education in 1980 to that in 1985?
Keep it short and to the point. 0.99. What is the ratio of the Female students (as % of total students) in Secondary vocational education in 1980 to that in 1985?
Your answer should be compact. 1.12. What is the ratio of the Female students (as % of total students) in Primary education in 1980 to that in 1986?
Your answer should be very brief. 1.01. What is the ratio of the Female students (as % of total students) of Tertiary education in 1980 to that in 1986?
Your response must be concise. 1.03. What is the ratio of the Female students (as % of total students) of Secondary general education in 1980 to that in 1986?
Offer a very short reply. 1.01. What is the ratio of the Female students (as % of total students) of Secondary vocational education in 1980 to that in 1986?
Offer a very short reply. 1.17. What is the ratio of the Female students (as % of total students) of Primary education in 1981 to that in 1982?
Provide a succinct answer. 0.99. What is the ratio of the Female students (as % of total students) in Tertiary education in 1981 to that in 1982?
Offer a terse response. 1.01. What is the ratio of the Female students (as % of total students) in Secondary general education in 1981 to that in 1982?
Your answer should be compact. 0.96. What is the ratio of the Female students (as % of total students) in Secondary vocational education in 1981 to that in 1982?
Provide a short and direct response. 1.13. What is the ratio of the Female students (as % of total students) of Primary education in 1981 to that in 1983?
Make the answer very short. 0.99. What is the ratio of the Female students (as % of total students) of Tertiary education in 1981 to that in 1983?
Ensure brevity in your answer.  1.03. What is the ratio of the Female students (as % of total students) of Secondary general education in 1981 to that in 1983?
Your answer should be compact. 0.96. What is the ratio of the Female students (as % of total students) of Secondary vocational education in 1981 to that in 1983?
Ensure brevity in your answer.  1.3. What is the ratio of the Female students (as % of total students) in Primary education in 1981 to that in 1984?
Make the answer very short. 1. What is the ratio of the Female students (as % of total students) in Tertiary education in 1981 to that in 1984?
Ensure brevity in your answer.  1.06. What is the ratio of the Female students (as % of total students) in Secondary general education in 1981 to that in 1984?
Your response must be concise. 0.97. What is the ratio of the Female students (as % of total students) in Secondary vocational education in 1981 to that in 1984?
Give a very brief answer. 1.23. What is the ratio of the Female students (as % of total students) of Primary education in 1981 to that in 1985?
Provide a short and direct response. 1.01. What is the ratio of the Female students (as % of total students) in Tertiary education in 1981 to that in 1985?
Provide a succinct answer. 1.07. What is the ratio of the Female students (as % of total students) in Secondary general education in 1981 to that in 1985?
Your answer should be very brief. 1. What is the ratio of the Female students (as % of total students) of Secondary vocational education in 1981 to that in 1985?
Give a very brief answer. 1.16. What is the ratio of the Female students (as % of total students) in Primary education in 1981 to that in 1986?
Give a very brief answer. 1.02. What is the ratio of the Female students (as % of total students) of Tertiary education in 1981 to that in 1986?
Provide a succinct answer. 1.08. What is the ratio of the Female students (as % of total students) in Secondary general education in 1981 to that in 1986?
Provide a succinct answer. 1.02. What is the ratio of the Female students (as % of total students) of Secondary vocational education in 1981 to that in 1986?
Provide a succinct answer. 1.21. What is the ratio of the Female students (as % of total students) of Tertiary education in 1982 to that in 1983?
Provide a succinct answer. 1.02. What is the ratio of the Female students (as % of total students) in Secondary general education in 1982 to that in 1983?
Your answer should be very brief. 1.01. What is the ratio of the Female students (as % of total students) in Secondary vocational education in 1982 to that in 1983?
Your answer should be very brief. 1.16. What is the ratio of the Female students (as % of total students) in Primary education in 1982 to that in 1984?
Your response must be concise. 1.01. What is the ratio of the Female students (as % of total students) of Tertiary education in 1982 to that in 1984?
Provide a short and direct response. 1.04. What is the ratio of the Female students (as % of total students) in Secondary general education in 1982 to that in 1984?
Offer a terse response. 1.02. What is the ratio of the Female students (as % of total students) in Secondary vocational education in 1982 to that in 1984?
Make the answer very short. 1.09. What is the ratio of the Female students (as % of total students) in Primary education in 1982 to that in 1985?
Provide a short and direct response. 1.02. What is the ratio of the Female students (as % of total students) in Tertiary education in 1982 to that in 1985?
Your answer should be very brief. 1.06. What is the ratio of the Female students (as % of total students) in Secondary general education in 1982 to that in 1985?
Your response must be concise. 1.04. What is the ratio of the Female students (as % of total students) in Secondary vocational education in 1982 to that in 1985?
Make the answer very short. 1.03. What is the ratio of the Female students (as % of total students) in Primary education in 1982 to that in 1986?
Offer a terse response. 1.03. What is the ratio of the Female students (as % of total students) in Tertiary education in 1982 to that in 1986?
Your answer should be compact. 1.06. What is the ratio of the Female students (as % of total students) of Secondary general education in 1982 to that in 1986?
Offer a terse response. 1.06. What is the ratio of the Female students (as % of total students) in Secondary vocational education in 1982 to that in 1986?
Ensure brevity in your answer.  1.07. What is the ratio of the Female students (as % of total students) in Primary education in 1983 to that in 1984?
Offer a terse response. 1.01. What is the ratio of the Female students (as % of total students) of Tertiary education in 1983 to that in 1984?
Provide a succinct answer. 1.02. What is the ratio of the Female students (as % of total students) in Secondary general education in 1983 to that in 1984?
Your answer should be very brief. 1.01. What is the ratio of the Female students (as % of total students) of Secondary vocational education in 1983 to that in 1984?
Provide a short and direct response. 0.94. What is the ratio of the Female students (as % of total students) in Primary education in 1983 to that in 1985?
Offer a terse response. 1.02. What is the ratio of the Female students (as % of total students) in Tertiary education in 1983 to that in 1985?
Keep it short and to the point. 1.04. What is the ratio of the Female students (as % of total students) in Secondary general education in 1983 to that in 1985?
Give a very brief answer. 1.04. What is the ratio of the Female students (as % of total students) in Secondary vocational education in 1983 to that in 1985?
Give a very brief answer. 0.89. What is the ratio of the Female students (as % of total students) in Primary education in 1983 to that in 1986?
Keep it short and to the point. 1.03. What is the ratio of the Female students (as % of total students) of Tertiary education in 1983 to that in 1986?
Your response must be concise. 1.04. What is the ratio of the Female students (as % of total students) in Secondary general education in 1983 to that in 1986?
Give a very brief answer. 1.06. What is the ratio of the Female students (as % of total students) of Secondary vocational education in 1983 to that in 1986?
Provide a short and direct response. 0.93. What is the ratio of the Female students (as % of total students) in Primary education in 1984 to that in 1985?
Ensure brevity in your answer.  1.01. What is the ratio of the Female students (as % of total students) in Tertiary education in 1984 to that in 1985?
Provide a succinct answer. 1.01. What is the ratio of the Female students (as % of total students) of Secondary general education in 1984 to that in 1985?
Offer a very short reply. 1.03. What is the ratio of the Female students (as % of total students) of Secondary vocational education in 1984 to that in 1985?
Keep it short and to the point. 0.94. What is the ratio of the Female students (as % of total students) in Primary education in 1984 to that in 1986?
Offer a very short reply. 1.02. What is the ratio of the Female students (as % of total students) of Tertiary education in 1984 to that in 1986?
Make the answer very short. 1.02. What is the ratio of the Female students (as % of total students) of Secondary general education in 1984 to that in 1986?
Offer a very short reply. 1.05. What is the ratio of the Female students (as % of total students) of Tertiary education in 1985 to that in 1986?
Offer a terse response. 1.01. What is the ratio of the Female students (as % of total students) of Secondary general education in 1985 to that in 1986?
Keep it short and to the point. 1.02. What is the ratio of the Female students (as % of total students) in Secondary vocational education in 1985 to that in 1986?
Your answer should be compact. 1.04. What is the difference between the highest and the second highest Female students (as % of total students) in Primary education?
Give a very brief answer. 0.14. What is the difference between the highest and the second highest Female students (as % of total students) of Tertiary education?
Provide a succinct answer. 0.33. What is the difference between the highest and the second highest Female students (as % of total students) in Secondary general education?
Make the answer very short. 0.13. What is the difference between the highest and the second highest Female students (as % of total students) in Secondary vocational education?
Keep it short and to the point. 1.09. What is the difference between the highest and the lowest Female students (as % of total students) in Primary education?
Your response must be concise. 1.21. What is the difference between the highest and the lowest Female students (as % of total students) in Tertiary education?
Your answer should be very brief. 1.79. What is the difference between the highest and the lowest Female students (as % of total students) of Secondary general education?
Provide a succinct answer. 1.49. What is the difference between the highest and the lowest Female students (as % of total students) of Secondary vocational education?
Your response must be concise. 7.14. 